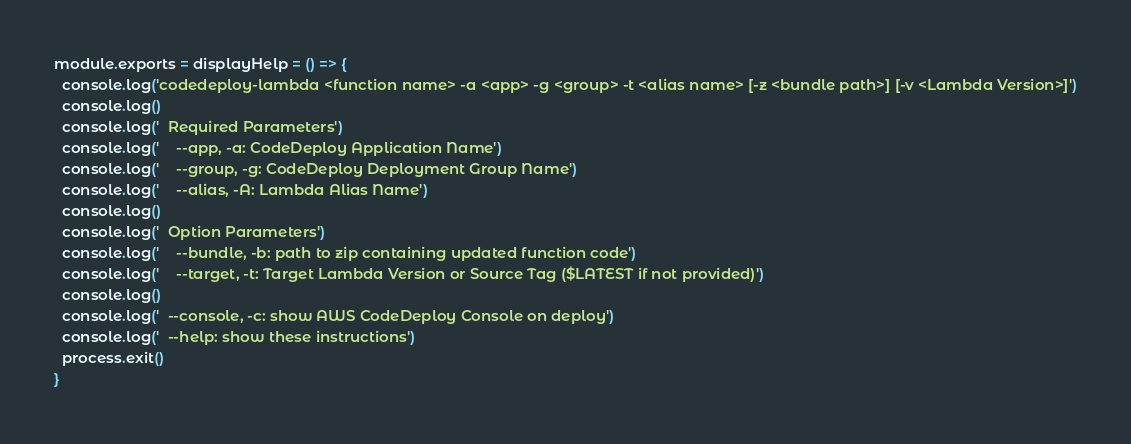Convert code to text. <code><loc_0><loc_0><loc_500><loc_500><_JavaScript_>module.exports = displayHelp = () => {
  console.log('codedeploy-lambda <function name> -a <app> -g <group> -t <alias name> [-z <bundle path>] [-v <Lambda Version>]')
  console.log()
  console.log('  Required Parameters')
  console.log('    --app, -a: CodeDeploy Application Name')
  console.log('    --group, -g: CodeDeploy Deployment Group Name')
  console.log('    --alias, -A: Lambda Alias Name')
  console.log()
  console.log('  Option Parameters')
  console.log('    --bundle, -b: path to zip containing updated function code')
  console.log('    --target, -t: Target Lambda Version or Source Tag ($LATEST if not provided)')
  console.log()
  console.log('  --console, -c: show AWS CodeDeploy Console on deploy')
  console.log('  --help: show these instructions')
  process.exit()
}</code> 